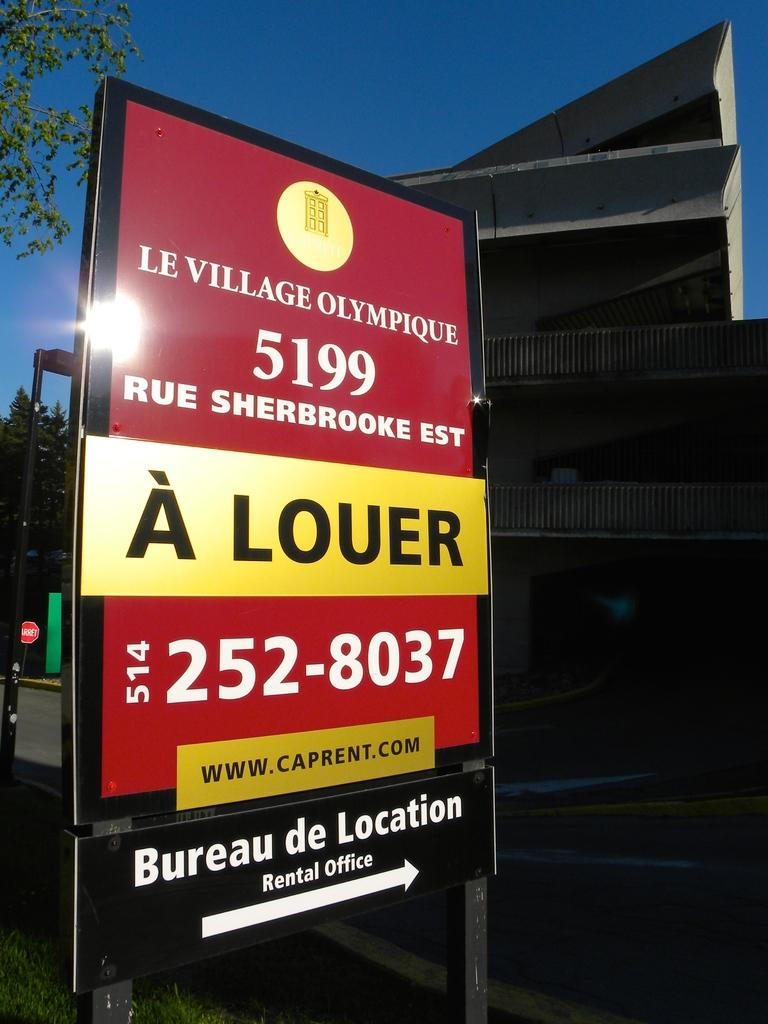<image>
Provide a brief description of the given image. a sign with the number 514-252-8037 on it 